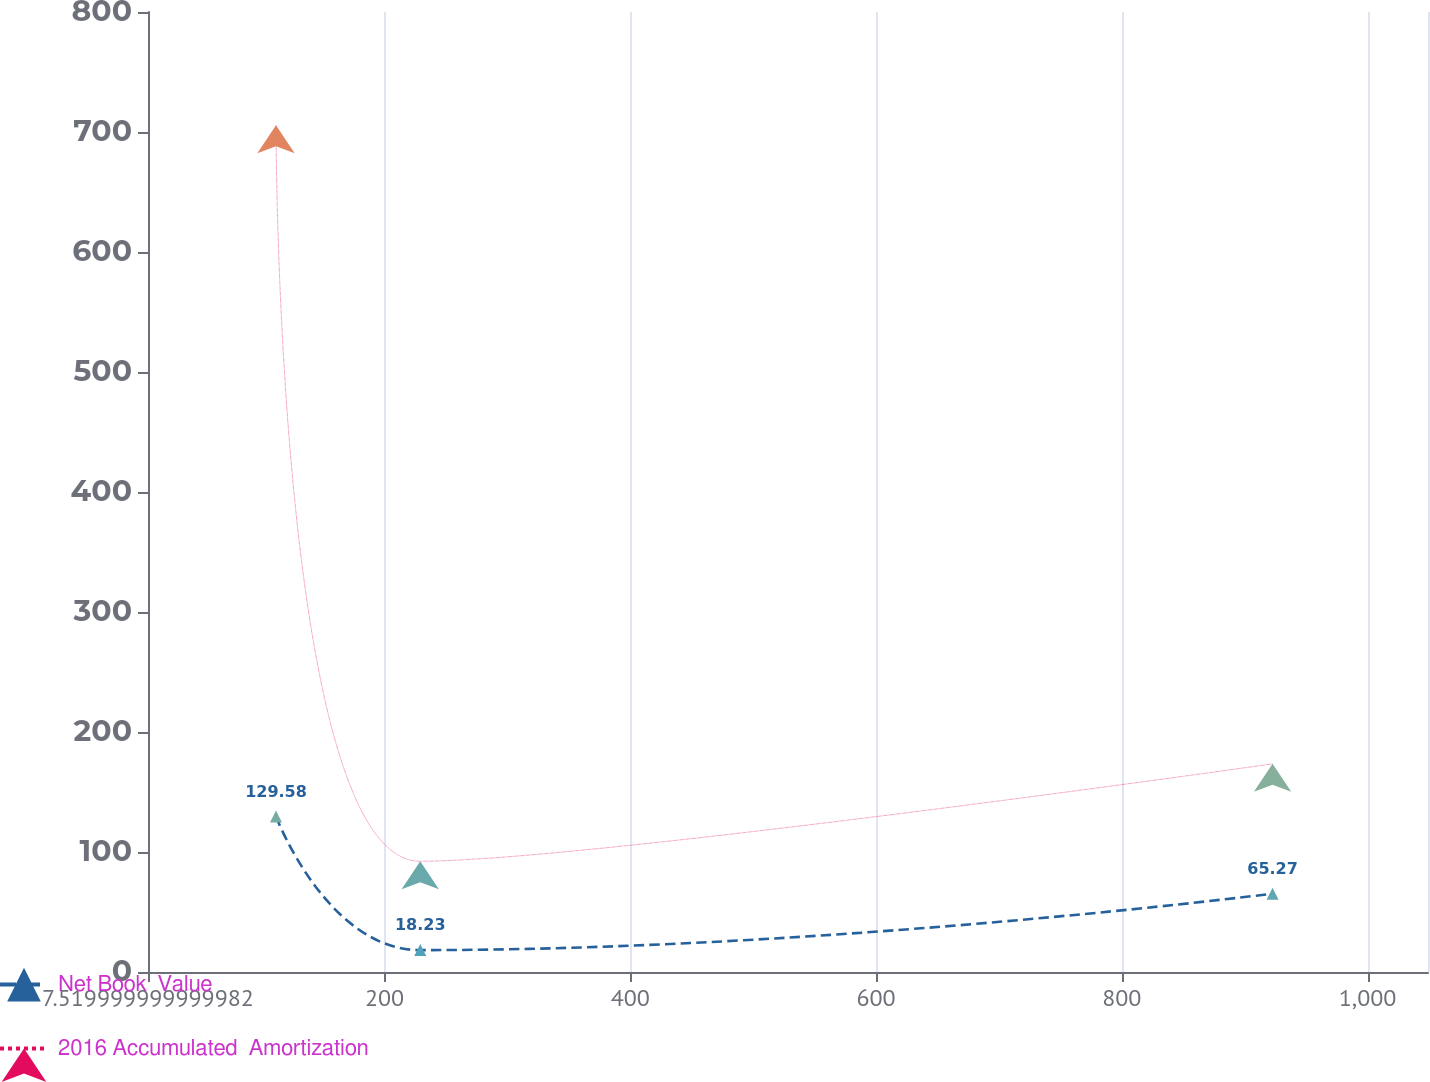<chart> <loc_0><loc_0><loc_500><loc_500><line_chart><ecel><fcel>Net Book  Value<fcel>2016 Accumulated  Amortization<nl><fcel>111.69<fcel>129.58<fcel>705.55<nl><fcel>229.07<fcel>18.23<fcel>92.3<nl><fcel>922.73<fcel>65.27<fcel>173.44<nl><fcel>1153.39<fcel>192.78<fcel>903.65<nl></chart> 